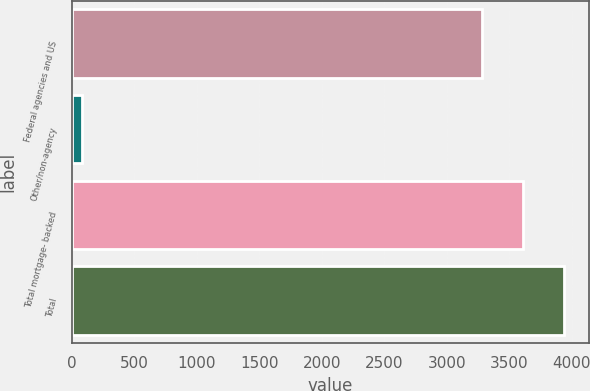Convert chart to OTSL. <chart><loc_0><loc_0><loc_500><loc_500><bar_chart><fcel>Federal agencies and US<fcel>Other/non-agency<fcel>Total mortgage- backed<fcel>Total<nl><fcel>3282<fcel>80<fcel>3610.2<fcel>3938.4<nl></chart> 